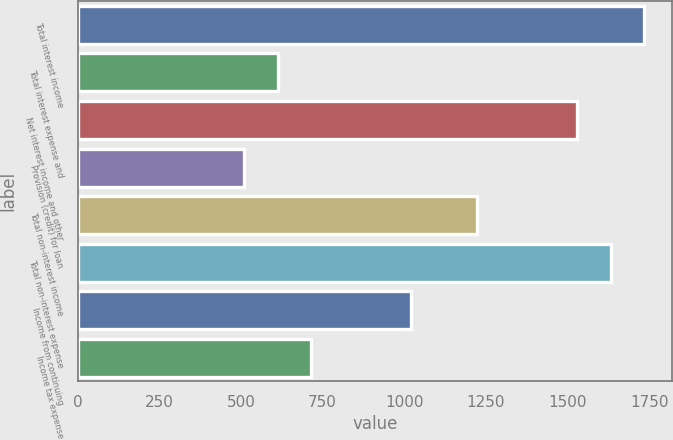<chart> <loc_0><loc_0><loc_500><loc_500><bar_chart><fcel>Total interest income<fcel>Total interest expense and<fcel>Net interest income and other<fcel>Provision (credit) for loan<fcel>Total non-interest income<fcel>Total non-interest expense<fcel>Income from continuing<fcel>Income tax expense<nl><fcel>1733.92<fcel>612.03<fcel>1529.94<fcel>510.04<fcel>1223.97<fcel>1631.93<fcel>1019.99<fcel>714.02<nl></chart> 